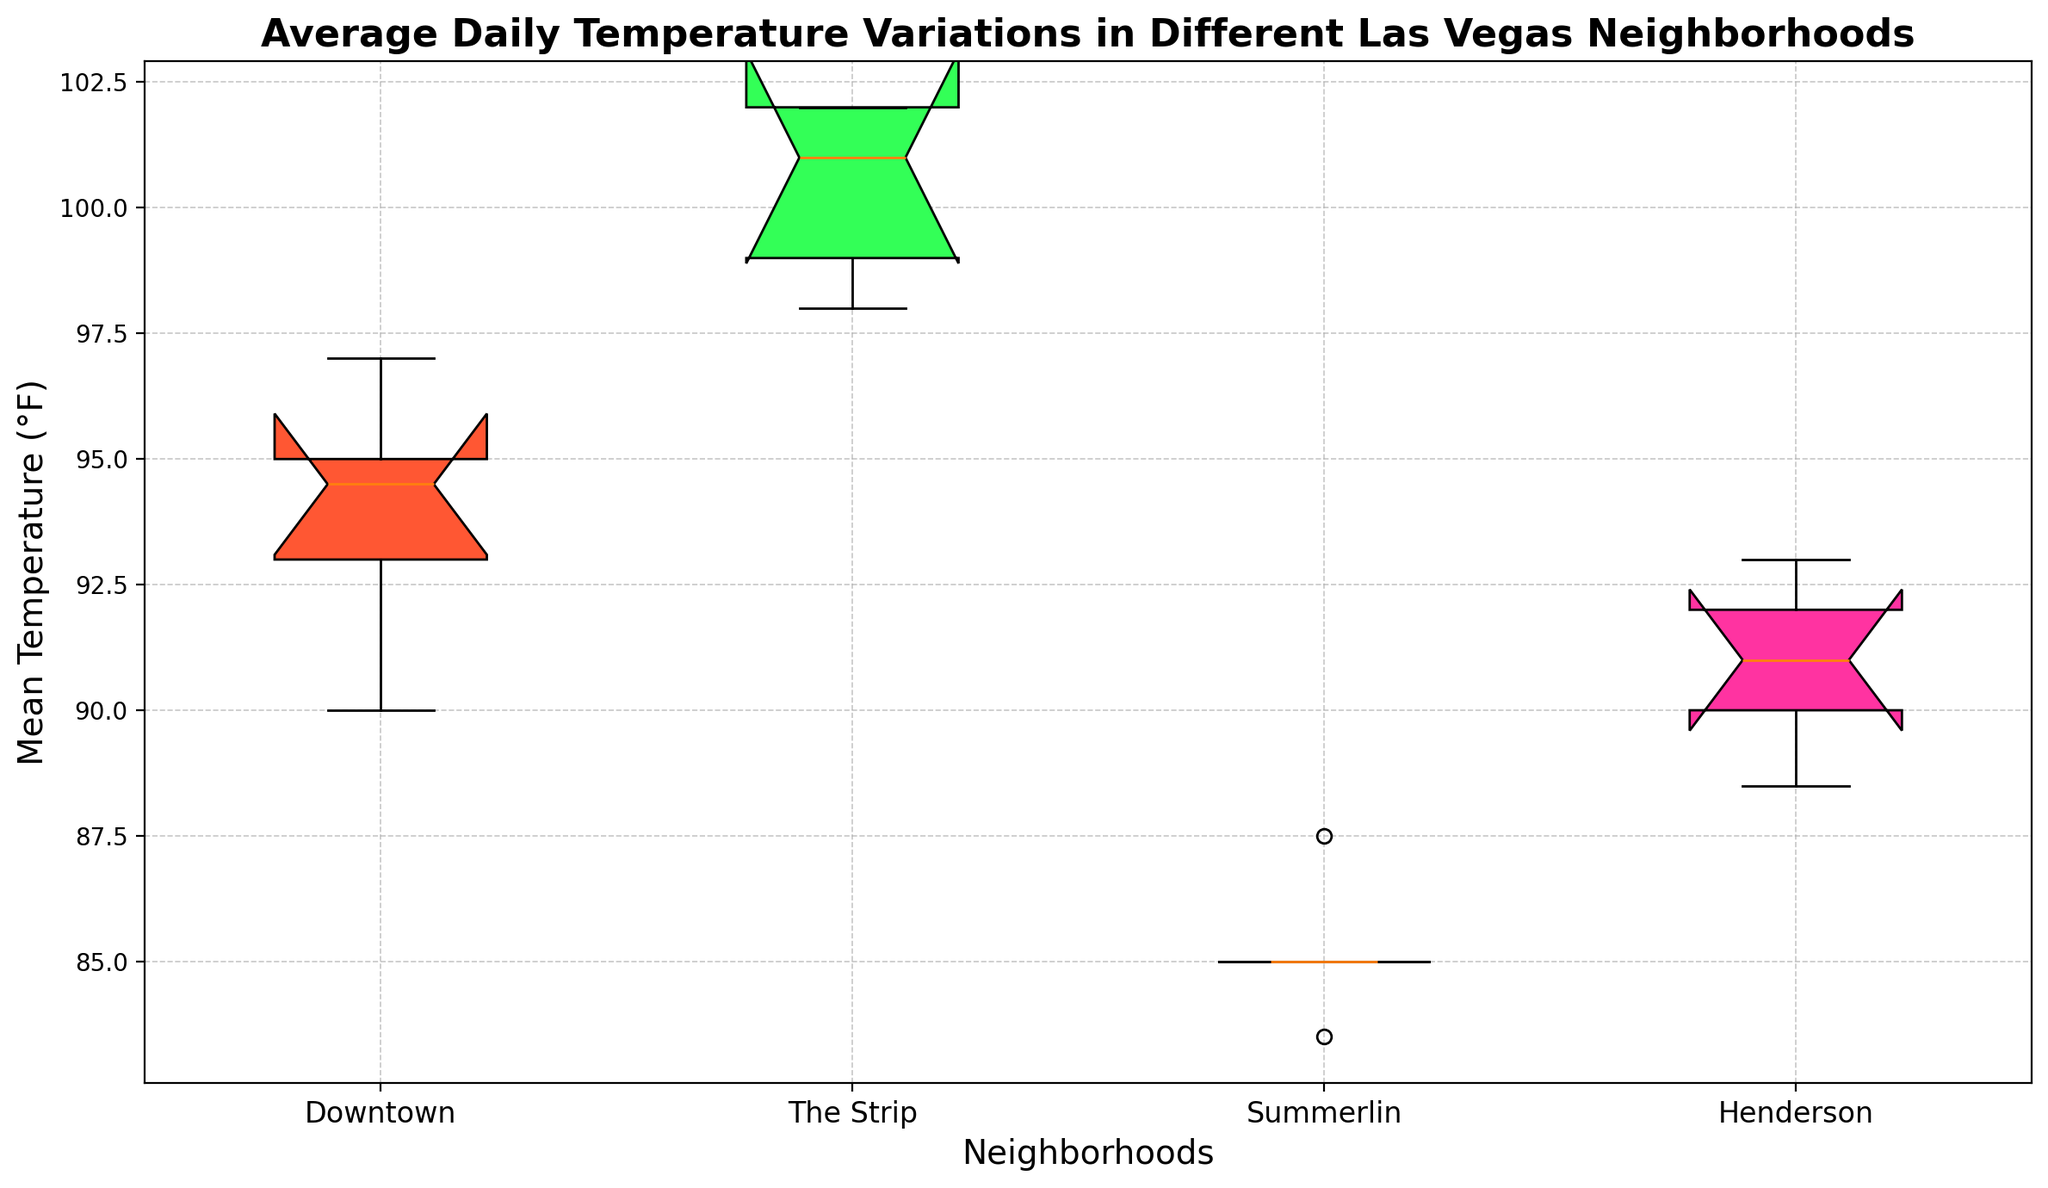What is the median mean temperature for "Downtown"? To find the median mean temperature for "Downtown," we need to locate the median line within the "Downtown" boxplot. The boxplot represents the distribution of mean temperatures for "Downtown," and the median is indicated by the thick line inside the box.
Answer: 94.5 Which neighborhood has the highest median mean temperature? From the boxplot, we compare the median lines of each neighborhood. The one with the highest median line represents the neighborhood with the highest median mean temperature. "The Strip" has the highest median line.
Answer: The Strip What is the interquartile range (IQR) of the mean temperature in "Summerlin"? The IQR is calculated as the difference between the upper quartile (Q3) and the lower quartile (Q1). For "Summerlin," the box represents the IQR, with the top and bottom of the box indicating Q3 and Q1, respectively.
Answer: 2.5 (Approximately, Q3 - Q1 = 87.5 - 85) Compare the variability of mean temperatures between "Downtown" and "Henderson". Which has a wider spread? The spread of the data in the boxplot is represented by the length of the whiskers and the range of the box. "Downtown" has a wider box and longer whiskers compared to "Henderson," indicating more variability.
Answer: Downtown Between which two neighborhoods is the temperature variation most similar? Temperature variation similarity can be compared by looking at the size and position of the boxes and whiskers. "Downtown" and "Henderson" have similar box sizes and whisker lengths, indicating similar variability.
Answer: Downtown and Henderson Which neighborhood has the smallest range of mean temperatures? The range is identified by the distance between the top and bottom whiskers. "Summerlin" has the smallest range as its whiskers are the closest.
Answer: Summerlin How does the color of the boxes help in identifying neighborhoods? Each neighborhood's box is colored differently: Downtown (first color), The Strip (second color), Summerlin (third color), and Henderson (fourth color). This helps in differentiating neighborhoods visually.
Answer: Different colors What can you infer about the mean temperatures in "The Strip" compared to other neighborhoods? "The Strip" has the highest median and also a higher overall range of mean temperatures compared to other neighborhoods, indicating it generally has higher and more variable mean temperatures.
Answer: Highest and most variable Which neighborhood has the lowest minimum temperature and what is it? The minimum temperature for each neighborhood is represented by the lowest whisker. "Summerlin" has the lowest whisker, indicating it has the lowest minimum temperature.
Answer: Summerlin How does the median mean temperature of "Summerlin" compare to the median mean temperature of "Henderson"? Comparing the median lines within the boxes for both neighborhoods shows that "Summerlin" has a lower median mean temperature than "Henderson."
Answer: Lower 